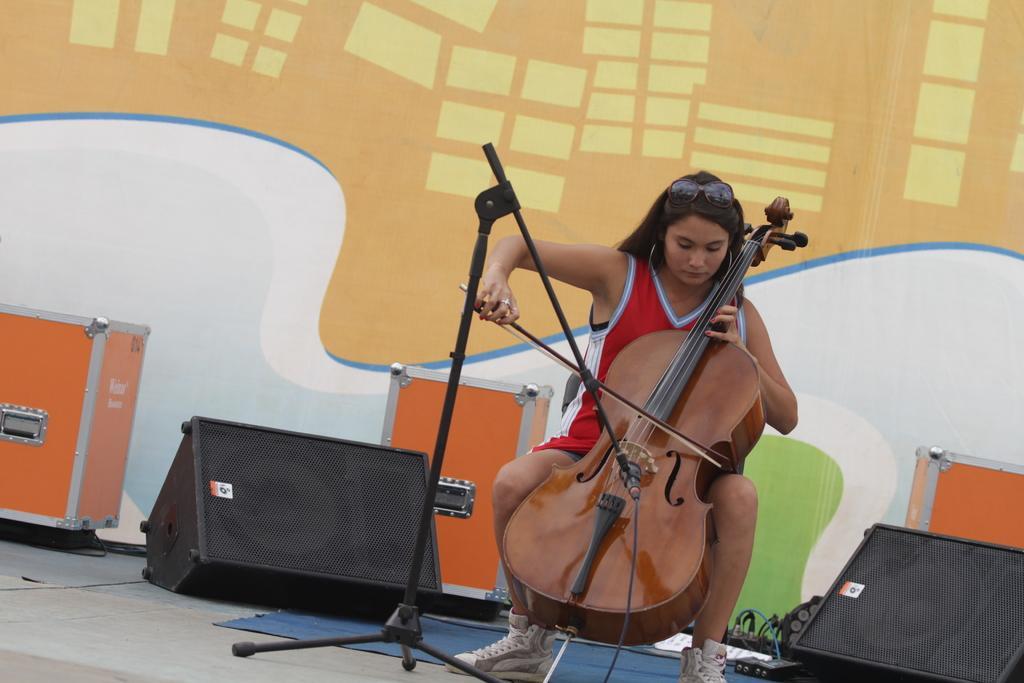Please provide a concise description of this image. In this image there is a person wearing red color dress sitting on the chair and playing violin in front of her there is a microphone and at the left side of the image there is a sound box and at the right side of the image there is a sound box. 